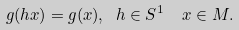Convert formula to latex. <formula><loc_0><loc_0><loc_500><loc_500>g ( h x ) = g ( x ) , \ h \in S ^ { 1 } \ \ x \in M .</formula> 